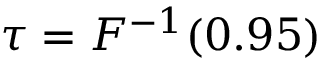<formula> <loc_0><loc_0><loc_500><loc_500>\tau = F ^ { - 1 } ( 0 . 9 5 )</formula> 